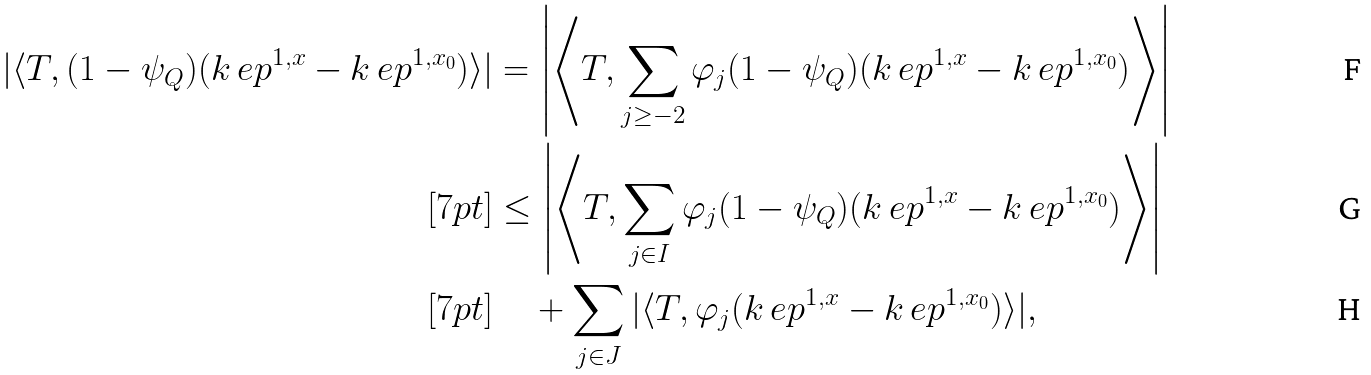Convert formula to latex. <formula><loc_0><loc_0><loc_500><loc_500>| \langle T , ( 1 - \psi _ { Q } ) ( k _ { \ } e p ^ { 1 , x } - k _ { \ } e p ^ { 1 , x _ { 0 } } ) \rangle | & = \left | \left \langle T , \sum _ { j \geq - 2 } \varphi _ { j } ( 1 - \psi _ { Q } ) ( k _ { \ } e p ^ { 1 , x } - k _ { \ } e p ^ { 1 , x _ { 0 } } ) \right \rangle \right | \\ [ 7 p t ] & \leq \left | \left \langle T , \sum _ { j \in I } \varphi _ { j } ( 1 - \psi _ { Q } ) ( k _ { \ } e p ^ { 1 , x } - k _ { \ } e p ^ { 1 , x _ { 0 } } ) \right \rangle \right | \\ [ 7 p t ] & \quad + \sum _ { j \in J } | \langle T , \varphi _ { j } ( k _ { \ } e p ^ { 1 , x } - k _ { \ } e p ^ { 1 , x _ { 0 } } ) \rangle | ,</formula> 